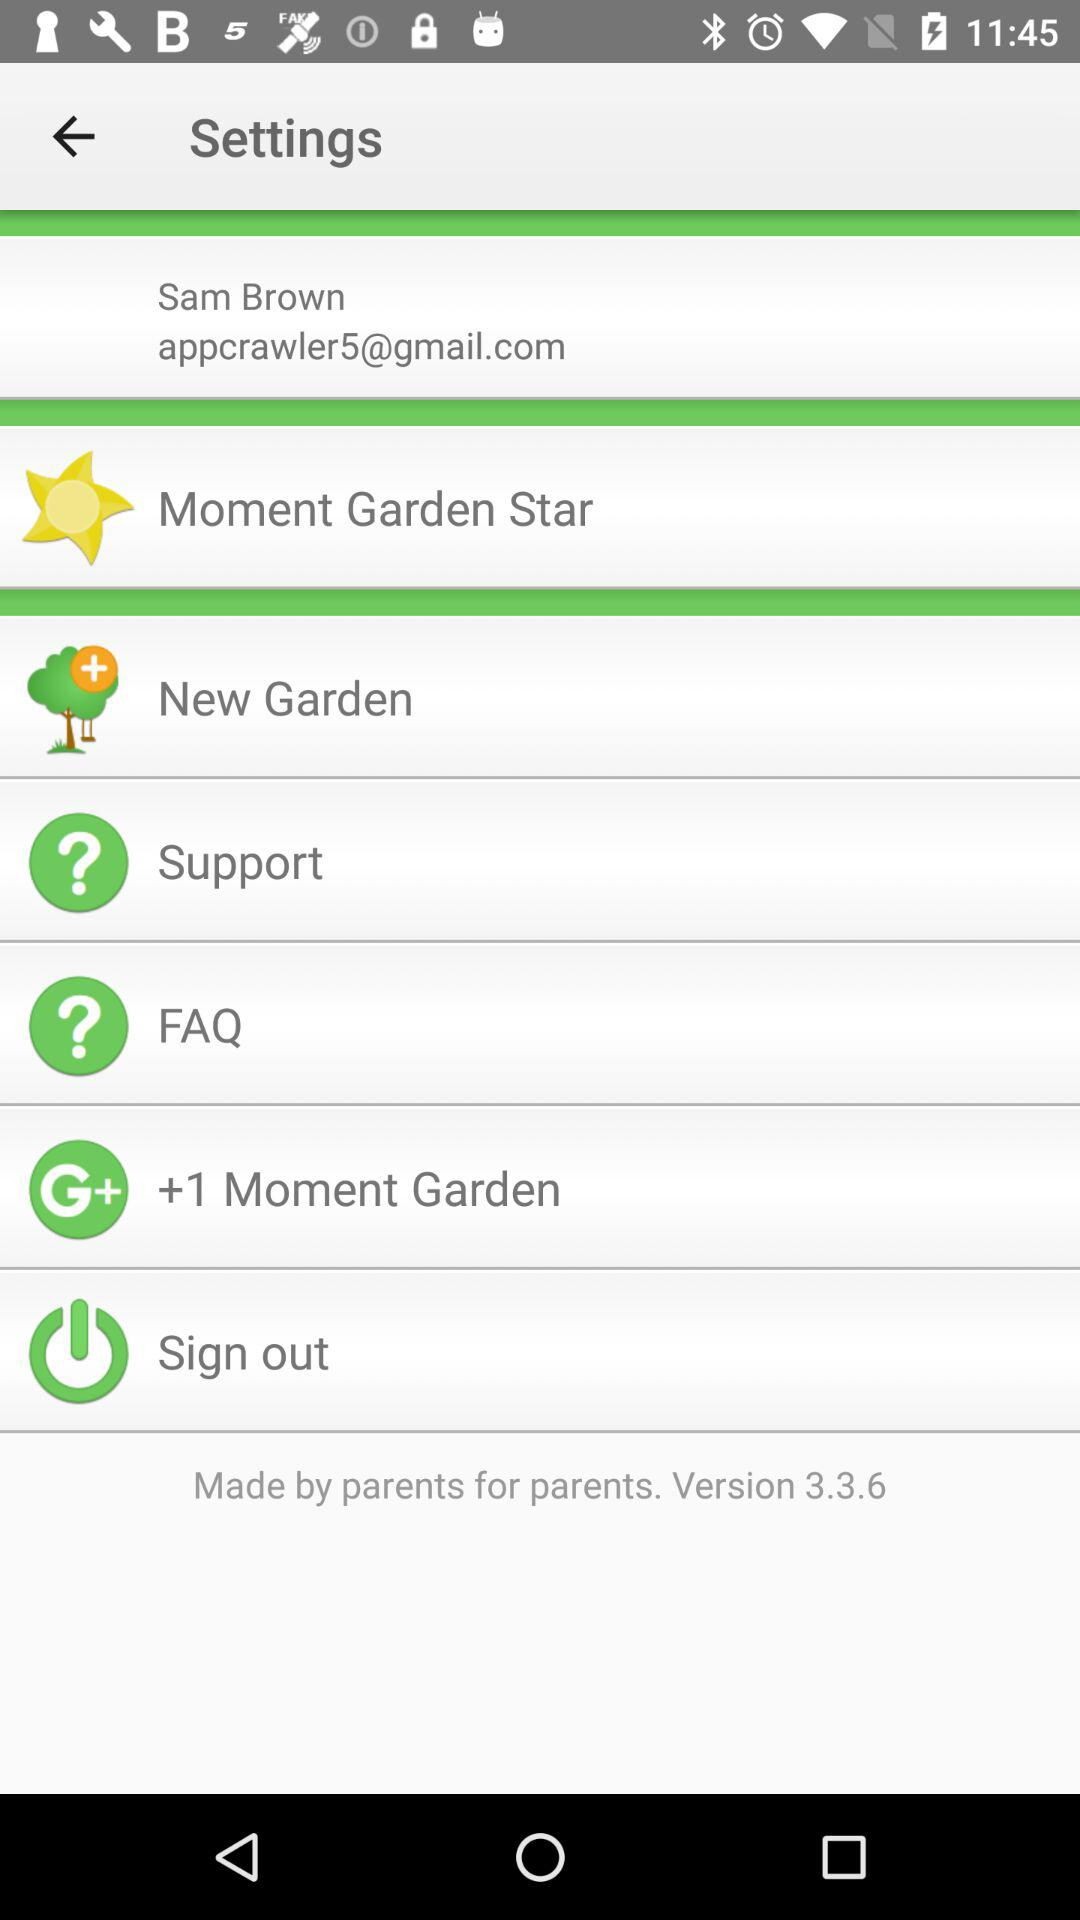What is the email address of the user? The email address of the user is appcrawler5@gmail.com. 